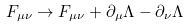Convert formula to latex. <formula><loc_0><loc_0><loc_500><loc_500>F _ { \mu \nu } \rightarrow F _ { \mu \nu } + \partial _ { \mu } \Lambda - \partial _ { \nu } \Lambda \quad</formula> 